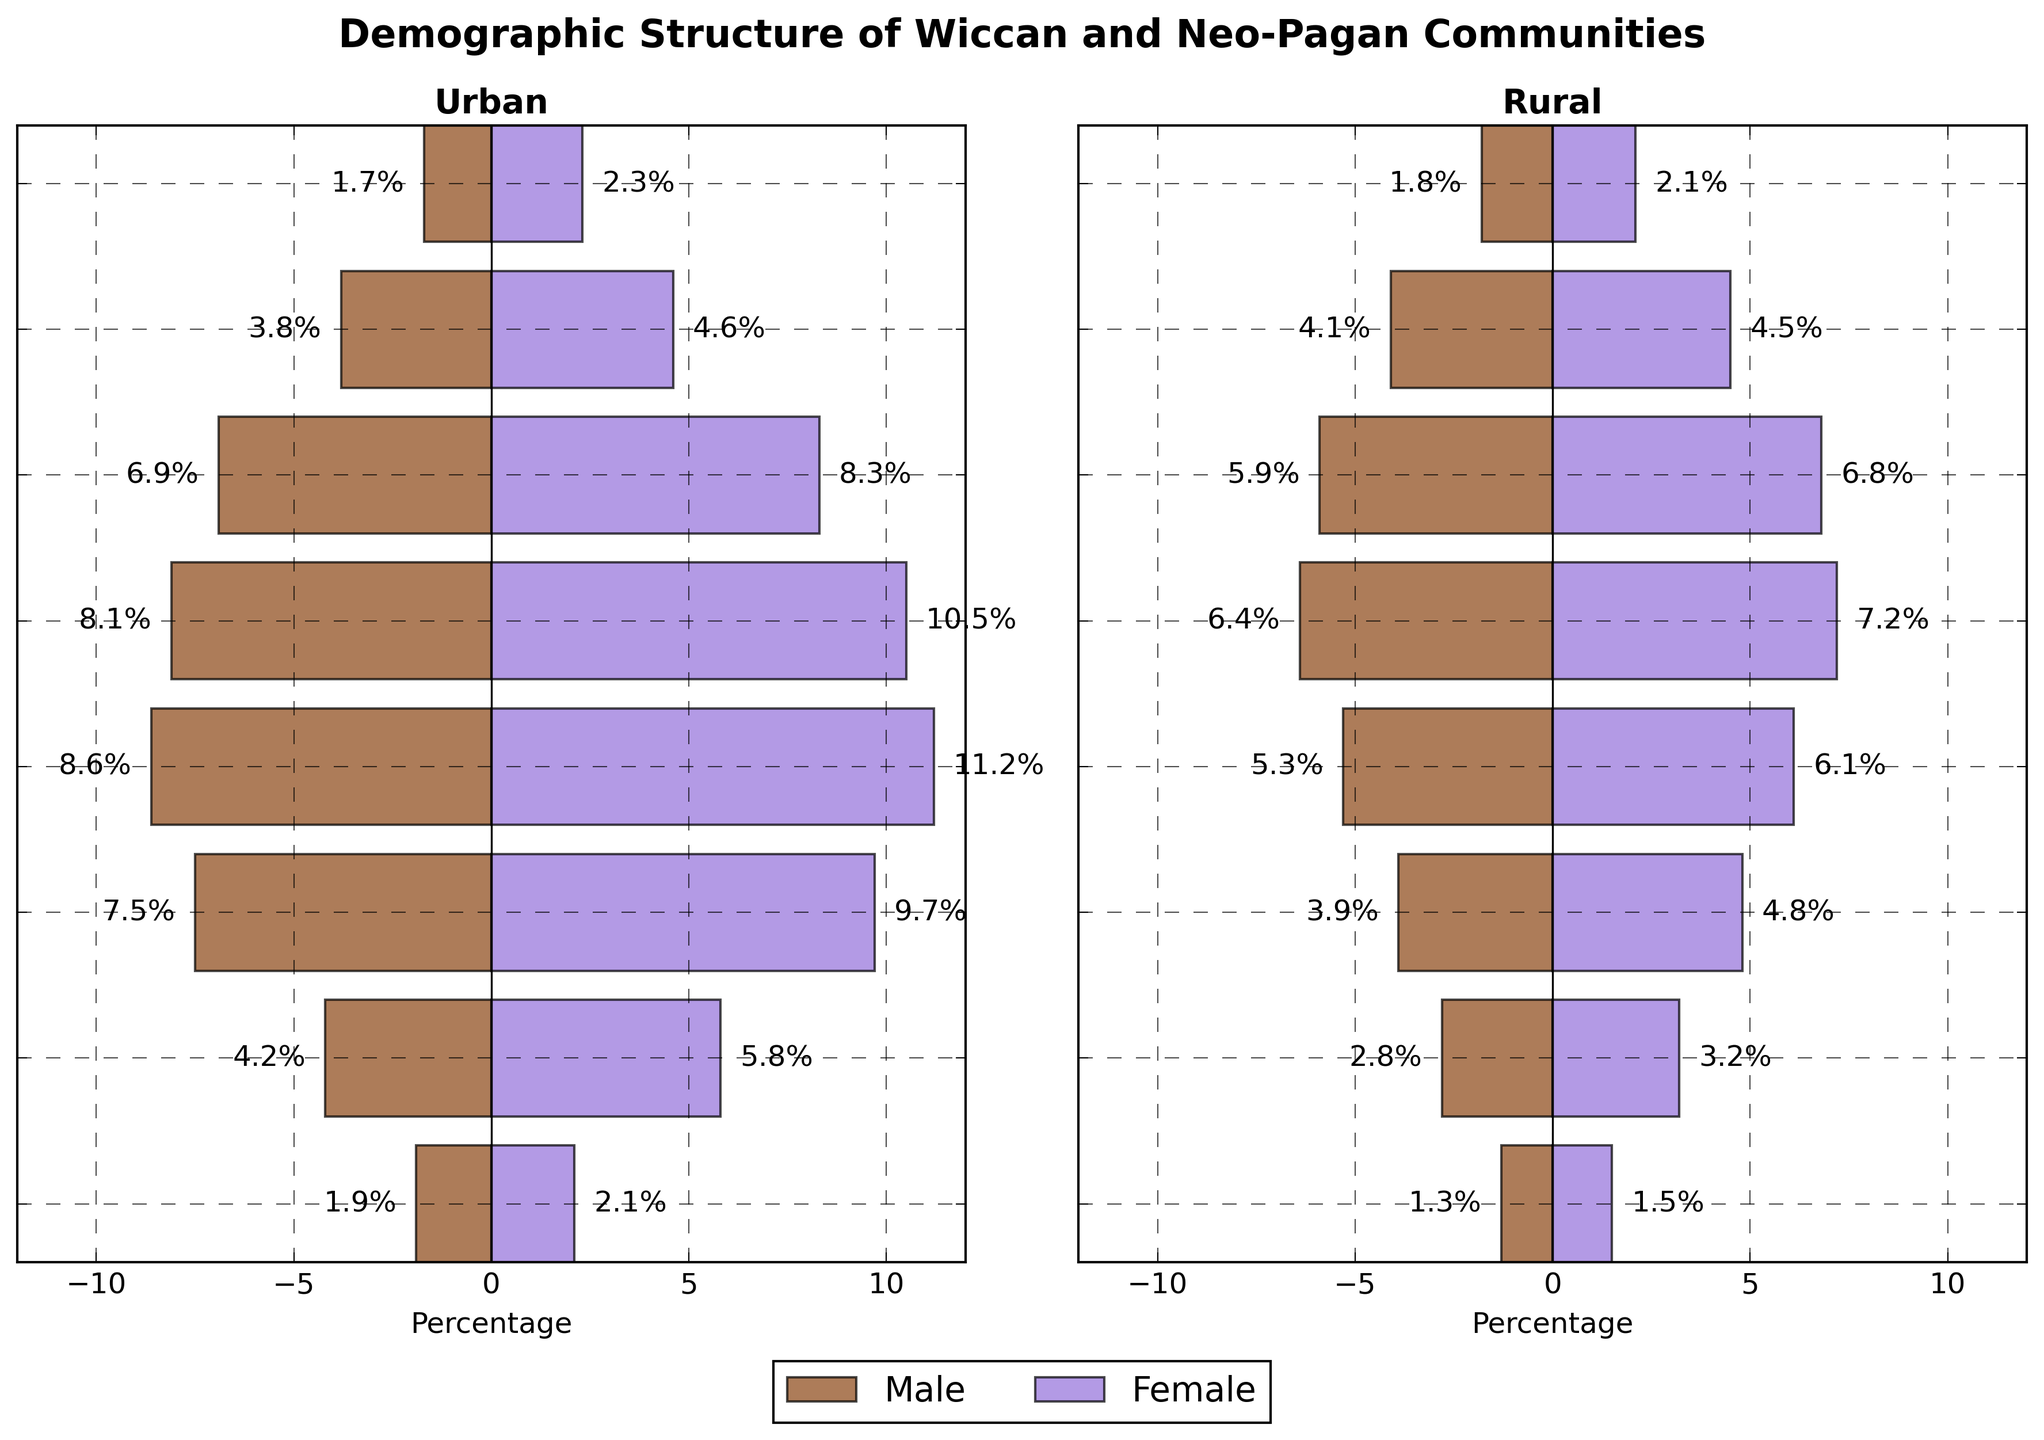How many age groups are represented in the figure? To find the number of age groups, count the distinctive labels on the y-axis. There are eight age groups: "0-14", "15-24", "25-34", "35-44", "45-54", "55-64", "65-74", and "75+".
Answer: Eight Which urban gender has the highest percentage in the "25-34" age group? For the "25-34" age group, look for the largest bar in the "Urban" section by comparing the length of the bars. The urban female group's bar is longer than the urban male group's bar.
Answer: Female Compare the percentage of rural females aged 65-74 to rural males aged 65-74. Which one is higher? Locate the "65-74" age group and compare the lengths of the rural female and rural male bars. The rural female bar (4.5%) is slightly longer than the rural male bar (4.1%).
Answer: Rural females What's the total percentage of urban Wiccan/Neo-Pagan males and females in the "45-54" age group? Sum the percentages of urban males and females in the "45-54" age group: 10.5% (female) + 8.1% (male).
Answer: 18.6% Which age group in the rural community has a higher percentage of both males and females compared to the "0-14" age group? Compare each age group's total percentage (male + female) to the "0-14" age group (2.1% females + 1.7% males = 2.1%). The "15-24", "25-34", "35-44", "45-54", "55-64", "65-74", and "75+" age groups all have higher totals.
Answer: All groups except "0-14" What's the overall trend in the percentage of urban females as age increases? Observe the bars for urban females from the youngest to the oldest age groups. The percentage increases up to "35-44" (11.2%) and then generally decreases from "45-54" (10.5%) onwards.
Answer: Rising then falling How do the percentages of rural males in the "55-64" and "65-74" age groups compare? Compare the rural male bars for these age groups: "55-64" (5.9%) and "65-74" (4.1%). The percentage is higher in the "55-64" age group.
Answer: "55-64" 